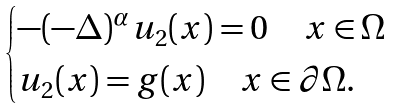Convert formula to latex. <formula><loc_0><loc_0><loc_500><loc_500>\begin{cases} - ( - \Delta ) ^ { \alpha } u _ { 2 } ( x ) = 0 \quad x \in \Omega \\ u _ { 2 } ( x ) = g ( x ) \quad x \in \partial \Omega . \end{cases}</formula> 